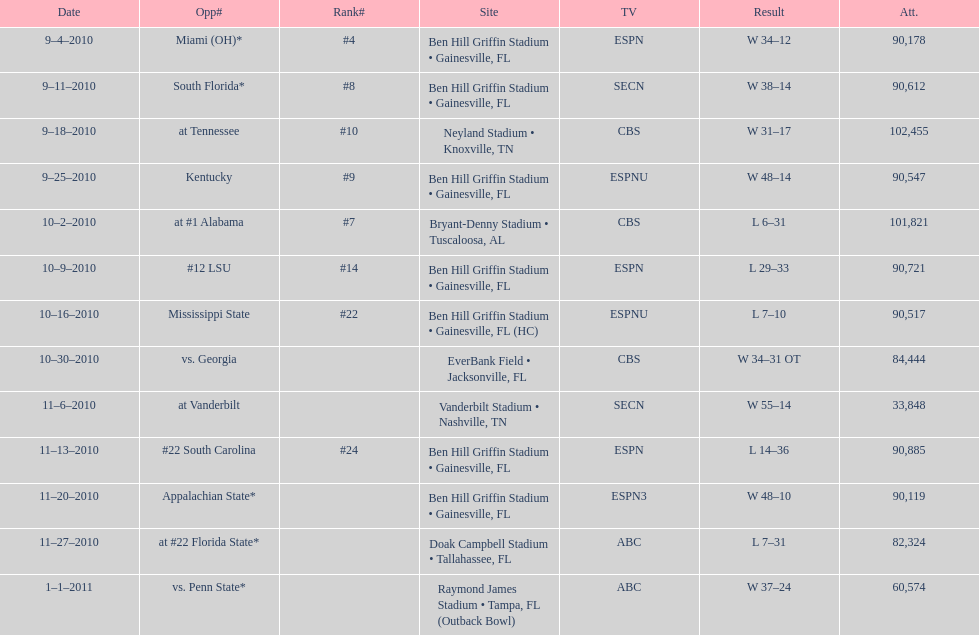How many consecutive weeks did the the gators win until the had their first lost in the 2010 season? 4. 